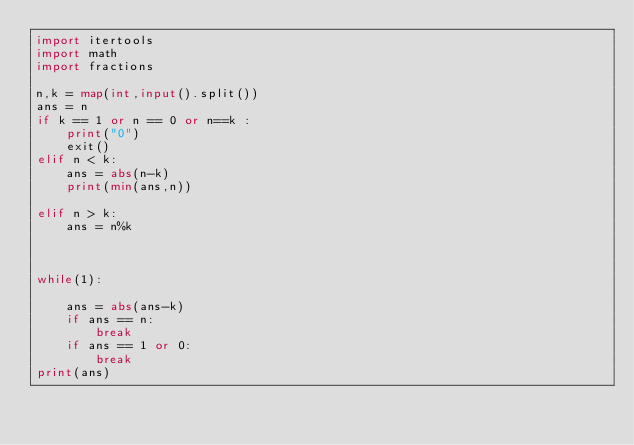<code> <loc_0><loc_0><loc_500><loc_500><_Python_>import itertools
import math
import fractions

n,k = map(int,input().split())
ans = n
if k == 1 or n == 0 or n==k :
    print("0")
    exit()
elif n < k:
    ans = abs(n-k)
    print(min(ans,n))

elif n > k:
    ans = n%k



while(1):
    
    ans = abs(ans-k)
    if ans == n:
        break
    if ans == 1 or 0:
        break
print(ans)</code> 